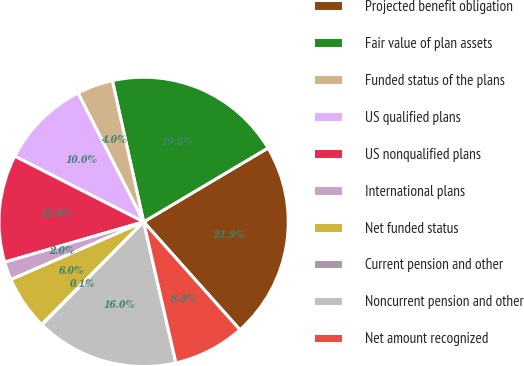Convert chart. <chart><loc_0><loc_0><loc_500><loc_500><pie_chart><fcel>Projected benefit obligation<fcel>Fair value of plan assets<fcel>Funded status of the plans<fcel>US qualified plans<fcel>US nonqualified plans<fcel>International plans<fcel>Net funded status<fcel>Current pension and other<fcel>Noncurrent pension and other<fcel>Net amount recognized<nl><fcel>21.93%<fcel>19.94%<fcel>4.03%<fcel>10.0%<fcel>11.99%<fcel>2.04%<fcel>6.02%<fcel>0.06%<fcel>15.97%<fcel>8.01%<nl></chart> 